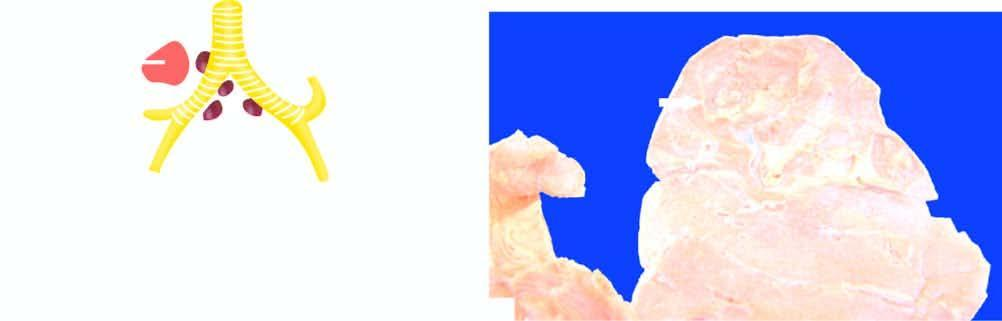what is consolidation of lung parenchyma surrounding?
Answer the question using a single word or phrase. The cavity 